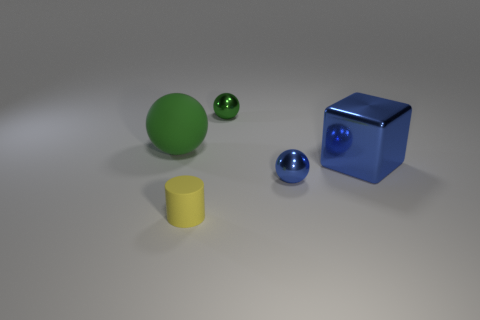Is the material of the small sphere that is behind the tiny blue ball the same as the large object on the right side of the large green thing?
Your response must be concise. Yes. What number of objects are either tiny green shiny balls or big green spheres behind the blue metal sphere?
Provide a succinct answer. 2. Is there a cyan shiny thing that has the same shape as the large matte thing?
Provide a succinct answer. No. What is the size of the green thing behind the green sphere in front of the shiny ball behind the large rubber thing?
Give a very brief answer. Small. Are there the same number of tiny green metal spheres in front of the small yellow cylinder and green shiny spheres behind the large block?
Keep it short and to the point. No. The ball that is made of the same material as the small cylinder is what size?
Your answer should be very brief. Large. The small matte thing is what color?
Ensure brevity in your answer.  Yellow. What number of tiny things have the same color as the tiny cylinder?
Ensure brevity in your answer.  0. There is a green ball that is the same size as the yellow matte cylinder; what material is it?
Provide a short and direct response. Metal. There is a small ball that is left of the small blue thing; are there any green rubber spheres that are behind it?
Keep it short and to the point. No. 